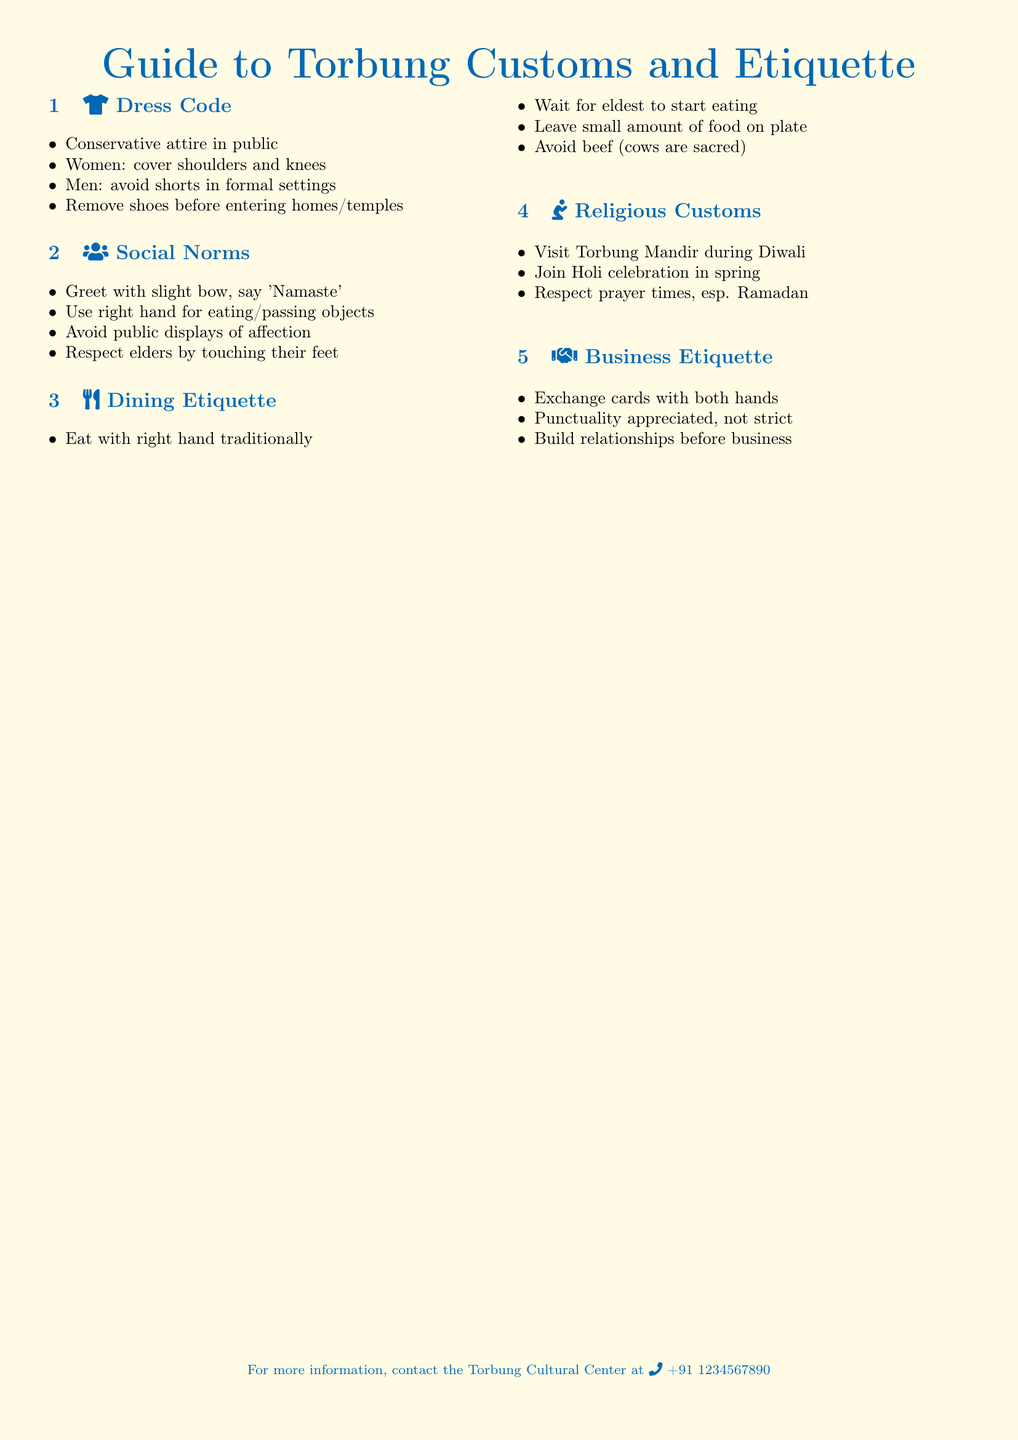What is the dress code for women? The dress code for women includes covering shoulders and knees in public.
Answer: cover shoulders and knees What should men avoid wearing in formal settings? In formal settings, men should avoid wearing shorts.
Answer: shorts What is the traditional way of greeting people? The traditional greeting involves a slight bow and saying 'Namaste'.
Answer: 'Namaste' What hand should be used for eating or passing objects? The right hand should be used for eating or passing objects.
Answer: right hand What is indicated about consuming beef in the etiquette? The document indicates that avoiding beef is important because cows are considered sacred.
Answer: avoid beef What is the recommended action before entering homes or temples? The recommended action is to remove shoes before entering homes or temples.
Answer: remove shoes When should one wait to start eating? One should wait for the eldest to start eating.
Answer: eldest What is appreciated in business etiquette regarding time? Punctuality is appreciated in business etiquette, though not considered strict.
Answer: appreciated What should be left on the plate after eating? A small amount of food should be left on the plate after eating.
Answer: small amount What celebration should be joined in the spring? The celebration to join in the spring is Holi.
Answer: Holi 